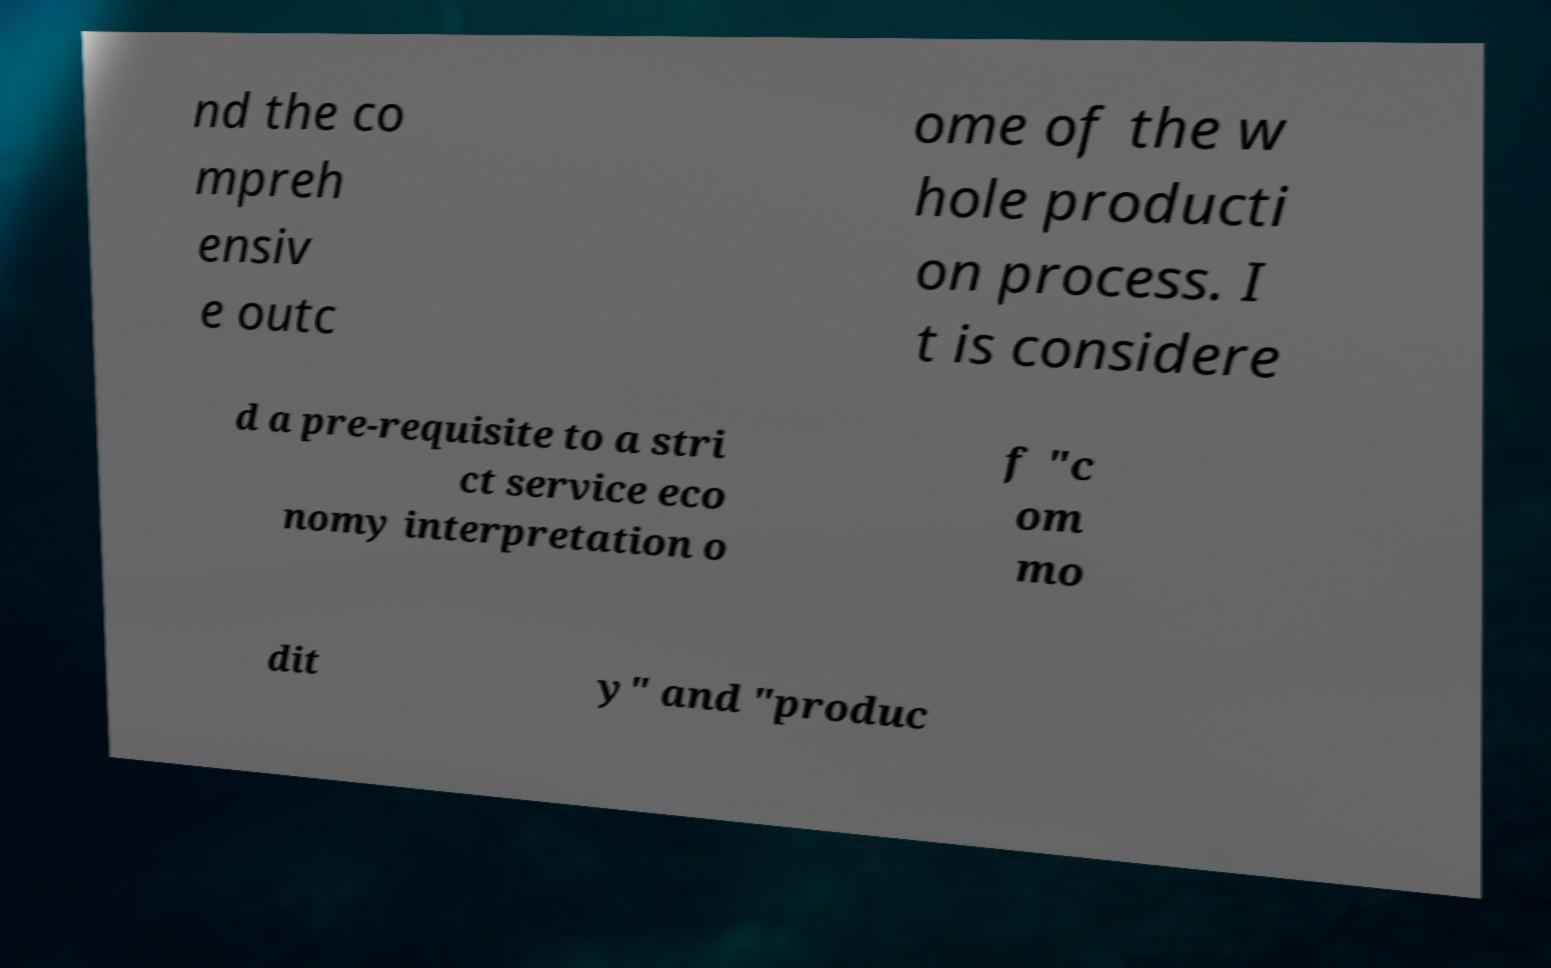Could you extract and type out the text from this image? nd the co mpreh ensiv e outc ome of the w hole producti on process. I t is considere d a pre-requisite to a stri ct service eco nomy interpretation o f "c om mo dit y" and "produc 